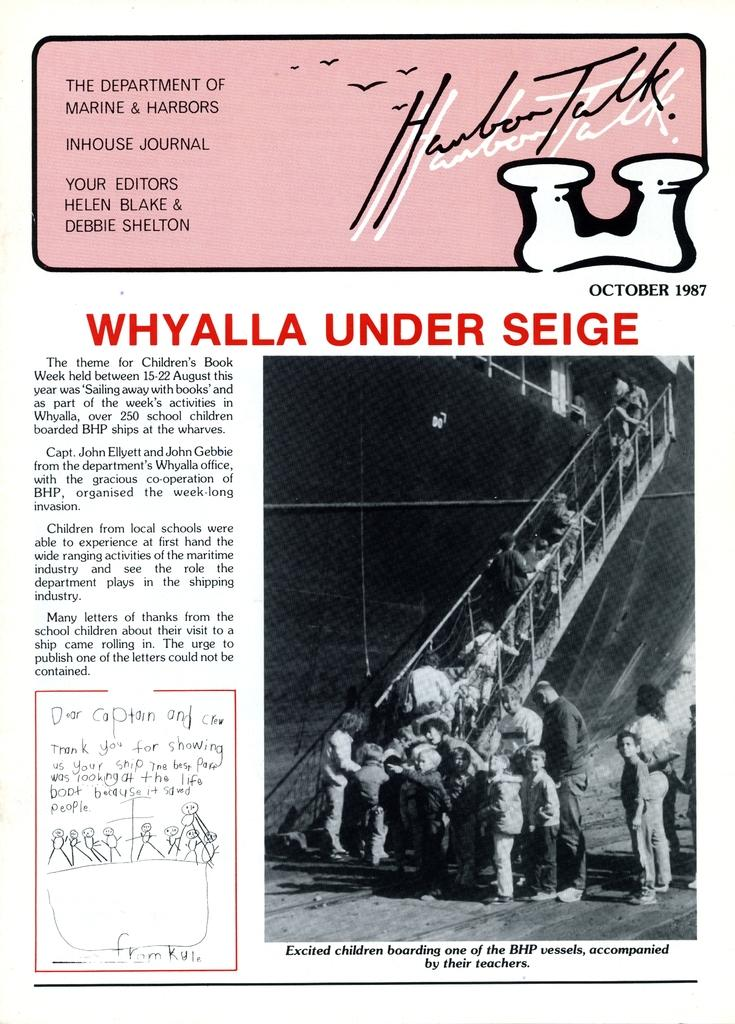<image>
Describe the image concisely. a paper that is from the department of marine and harbors 